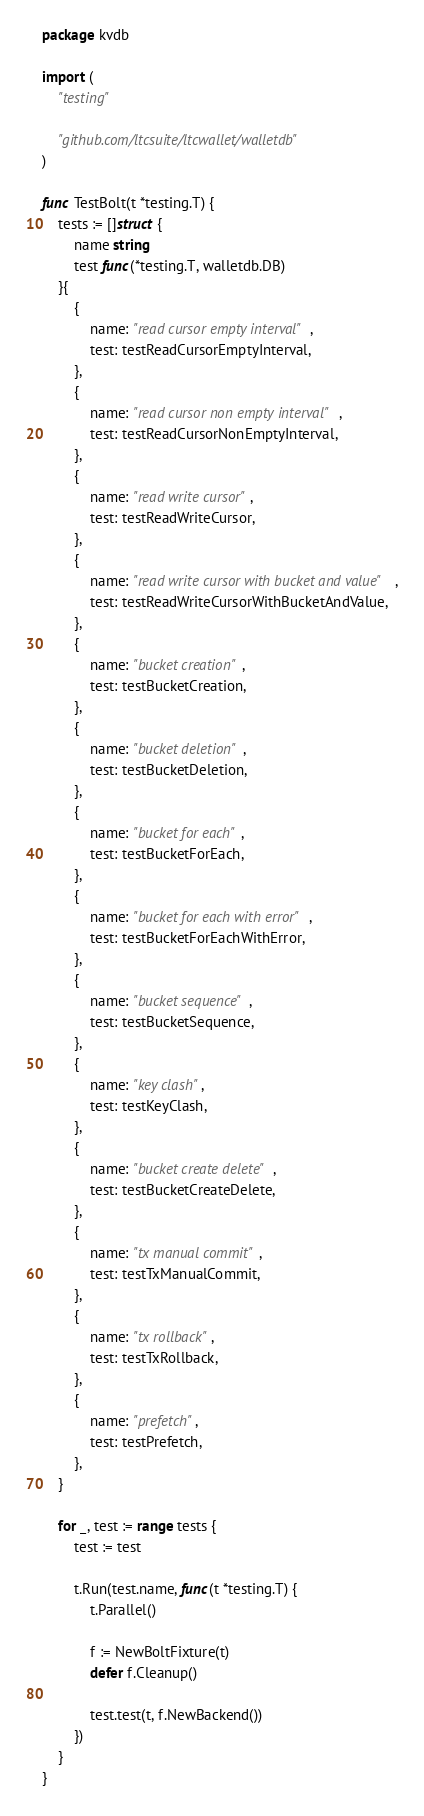Convert code to text. <code><loc_0><loc_0><loc_500><loc_500><_Go_>package kvdb

import (
	"testing"

	"github.com/ltcsuite/ltcwallet/walletdb"
)

func TestBolt(t *testing.T) {
	tests := []struct {
		name string
		test func(*testing.T, walletdb.DB)
	}{
		{
			name: "read cursor empty interval",
			test: testReadCursorEmptyInterval,
		},
		{
			name: "read cursor non empty interval",
			test: testReadCursorNonEmptyInterval,
		},
		{
			name: "read write cursor",
			test: testReadWriteCursor,
		},
		{
			name: "read write cursor with bucket and value",
			test: testReadWriteCursorWithBucketAndValue,
		},
		{
			name: "bucket creation",
			test: testBucketCreation,
		},
		{
			name: "bucket deletion",
			test: testBucketDeletion,
		},
		{
			name: "bucket for each",
			test: testBucketForEach,
		},
		{
			name: "bucket for each with error",
			test: testBucketForEachWithError,
		},
		{
			name: "bucket sequence",
			test: testBucketSequence,
		},
		{
			name: "key clash",
			test: testKeyClash,
		},
		{
			name: "bucket create delete",
			test: testBucketCreateDelete,
		},
		{
			name: "tx manual commit",
			test: testTxManualCommit,
		},
		{
			name: "tx rollback",
			test: testTxRollback,
		},
		{
			name: "prefetch",
			test: testPrefetch,
		},
	}

	for _, test := range tests {
		test := test

		t.Run(test.name, func(t *testing.T) {
			t.Parallel()

			f := NewBoltFixture(t)
			defer f.Cleanup()

			test.test(t, f.NewBackend())
		})
	}
}
</code> 